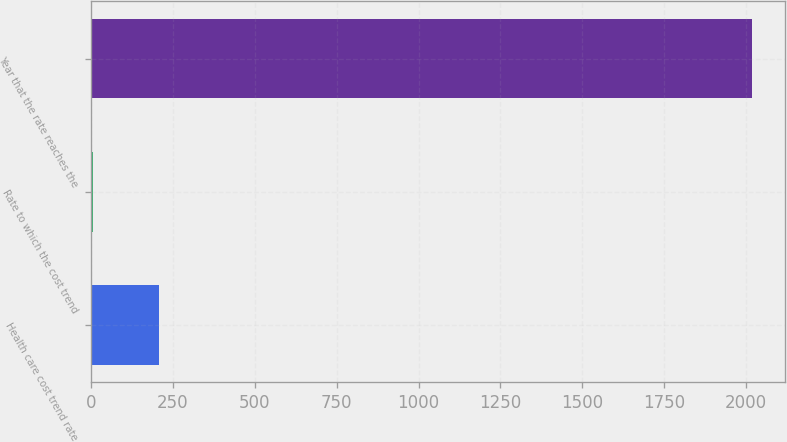<chart> <loc_0><loc_0><loc_500><loc_500><bar_chart><fcel>Health care cost trend rate<fcel>Rate to which the cost trend<fcel>Year that the rate reaches the<nl><fcel>205.84<fcel>4.49<fcel>2018<nl></chart> 